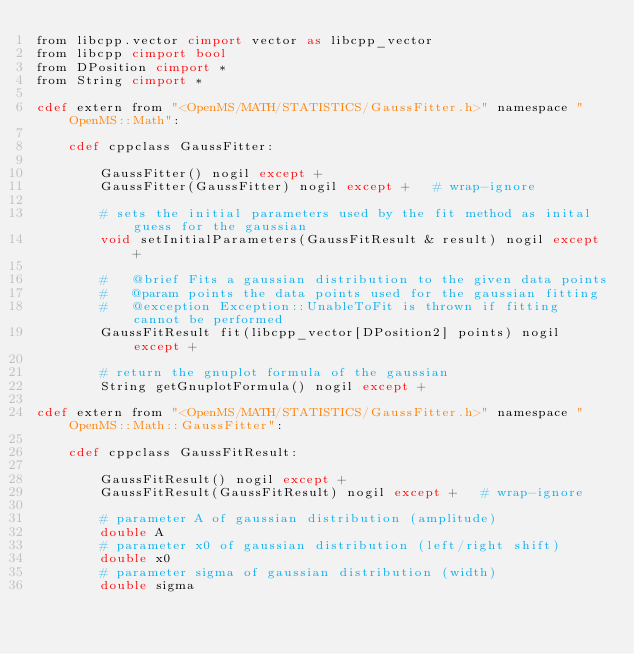Convert code to text. <code><loc_0><loc_0><loc_500><loc_500><_Cython_>from libcpp.vector cimport vector as libcpp_vector
from libcpp cimport bool
from DPosition cimport *
from String cimport *

cdef extern from "<OpenMS/MATH/STATISTICS/GaussFitter.h>" namespace "OpenMS::Math":

    cdef cppclass GaussFitter:

        GaussFitter() nogil except +
        GaussFitter(GaussFitter) nogil except +   # wrap-ignore

        # sets the initial parameters used by the fit method as inital guess for the gaussian
        void setInitialParameters(GaussFitResult & result) nogil except +

        #   @brief Fits a gaussian distribution to the given data points
        #   @param points the data points used for the gaussian fitting
        #   @exception Exception::UnableToFit is thrown if fitting cannot be performed
        GaussFitResult fit(libcpp_vector[DPosition2] points) nogil except +

        # return the gnuplot formula of the gaussian
        String getGnuplotFormula() nogil except +

cdef extern from "<OpenMS/MATH/STATISTICS/GaussFitter.h>" namespace "OpenMS::Math::GaussFitter":

    cdef cppclass GaussFitResult:

        GaussFitResult() nogil except +
        GaussFitResult(GaussFitResult) nogil except +   # wrap-ignore

        # parameter A of gaussian distribution (amplitude)
        double A
        # parameter x0 of gaussian distribution (left/right shift)
        double x0
        # parameter sigma of gaussian distribution (width)
        double sigma
</code> 